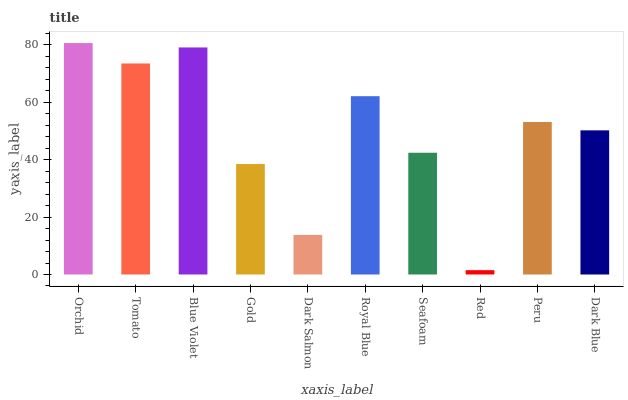Is Tomato the minimum?
Answer yes or no. No. Is Tomato the maximum?
Answer yes or no. No. Is Orchid greater than Tomato?
Answer yes or no. Yes. Is Tomato less than Orchid?
Answer yes or no. Yes. Is Tomato greater than Orchid?
Answer yes or no. No. Is Orchid less than Tomato?
Answer yes or no. No. Is Peru the high median?
Answer yes or no. Yes. Is Dark Blue the low median?
Answer yes or no. Yes. Is Seafoam the high median?
Answer yes or no. No. Is Tomato the low median?
Answer yes or no. No. 